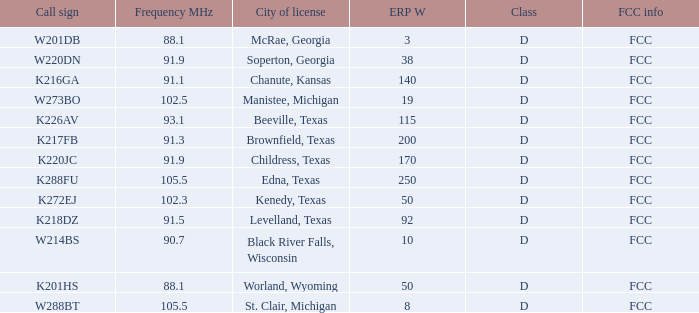Would you mind parsing the complete table? {'header': ['Call sign', 'Frequency MHz', 'City of license', 'ERP W', 'Class', 'FCC info'], 'rows': [['W201DB', '88.1', 'McRae, Georgia', '3', 'D', 'FCC'], ['W220DN', '91.9', 'Soperton, Georgia', '38', 'D', 'FCC'], ['K216GA', '91.1', 'Chanute, Kansas', '140', 'D', 'FCC'], ['W273BO', '102.5', 'Manistee, Michigan', '19', 'D', 'FCC'], ['K226AV', '93.1', 'Beeville, Texas', '115', 'D', 'FCC'], ['K217FB', '91.3', 'Brownfield, Texas', '200', 'D', 'FCC'], ['K220JC', '91.9', 'Childress, Texas', '170', 'D', 'FCC'], ['K288FU', '105.5', 'Edna, Texas', '250', 'D', 'FCC'], ['K272EJ', '102.3', 'Kenedy, Texas', '50', 'D', 'FCC'], ['K218DZ', '91.5', 'Levelland, Texas', '92', 'D', 'FCC'], ['W214BS', '90.7', 'Black River Falls, Wisconsin', '10', 'D', 'FCC'], ['K201HS', '88.1', 'Worland, Wyoming', '50', 'D', 'FCC'], ['W288BT', '105.5', 'St. Clair, Michigan', '8', 'D', 'FCC']]} What is the licensing city when the frequency mhz is lesser than 10 McRae, Georgia, Soperton, Georgia, Chanute, Kansas, Beeville, Texas, Brownfield, Texas, Childress, Texas, Kenedy, Texas, Levelland, Texas, Black River Falls, Wisconsin, Worland, Wyoming. 